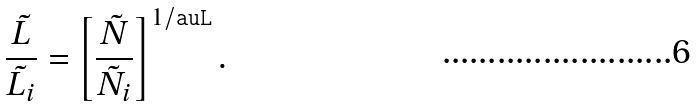<formula> <loc_0><loc_0><loc_500><loc_500>\frac { \tilde { L } } { \tilde { L } _ { i } } = \left [ \frac { \tilde { N } } { \tilde { N } _ { i } } \right ] ^ { 1 / \tt a u L } .</formula> 